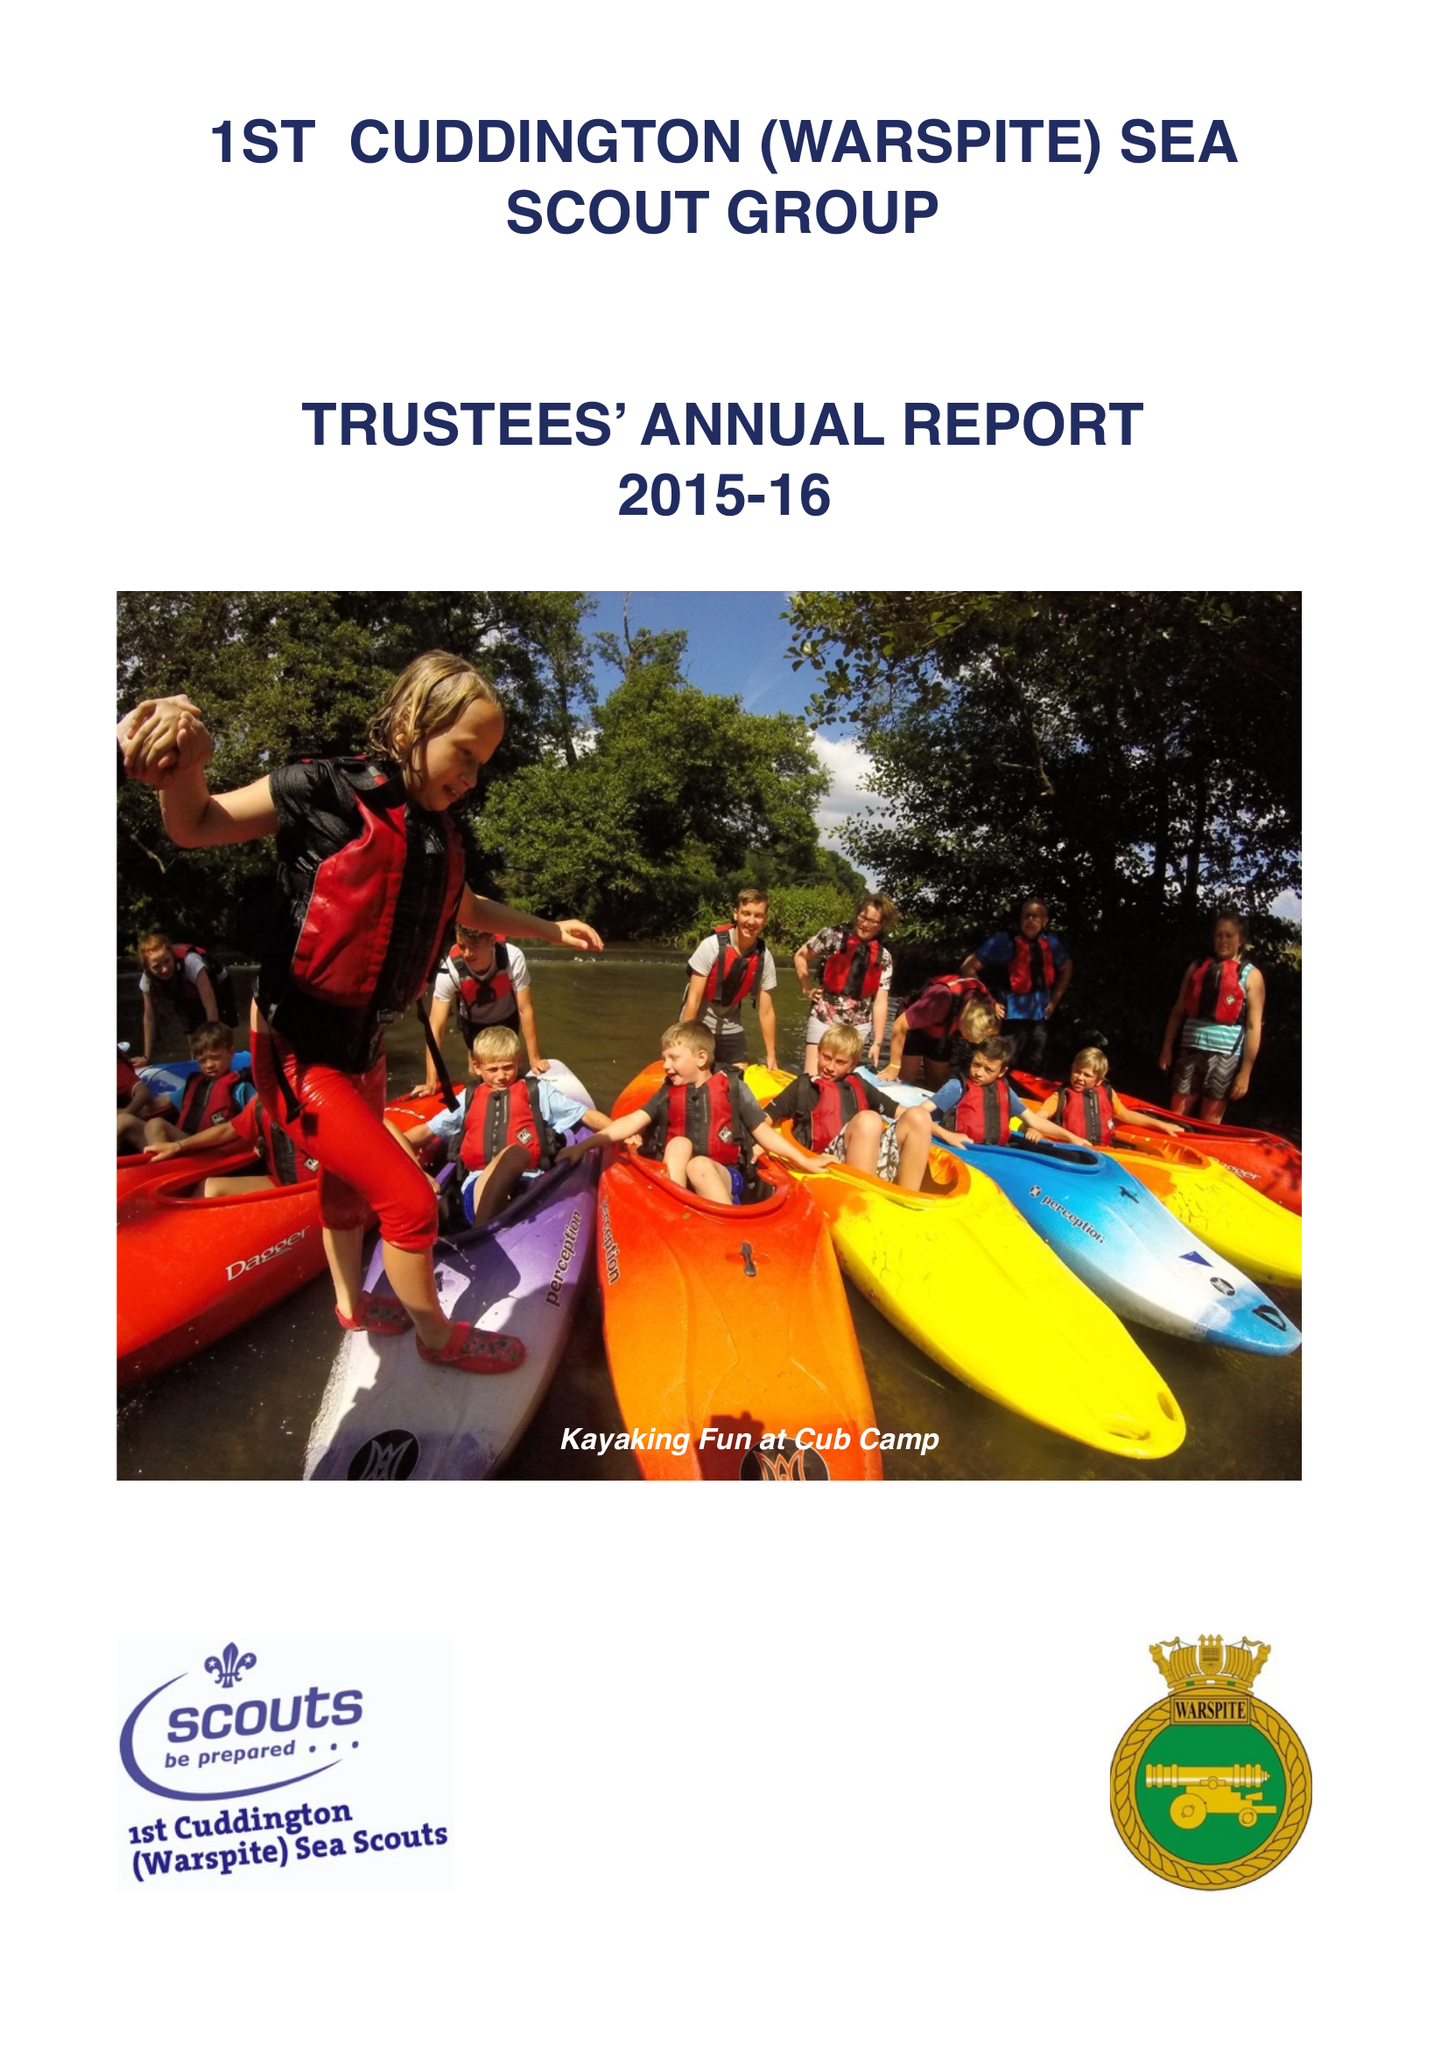What is the value for the income_annually_in_british_pounds?
Answer the question using a single word or phrase. 81709.00 